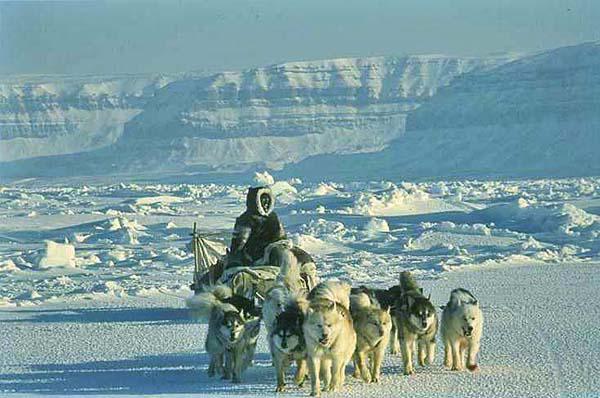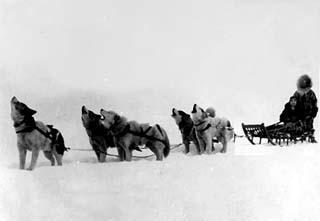The first image is the image on the left, the second image is the image on the right. Considering the images on both sides, is "All the dogs are moving forward." valid? Answer yes or no. No. The first image is the image on the left, the second image is the image on the right. Analyze the images presented: Is the assertion "in one of the images, a dogsled is headed towards the right." valid? Answer yes or no. No. 